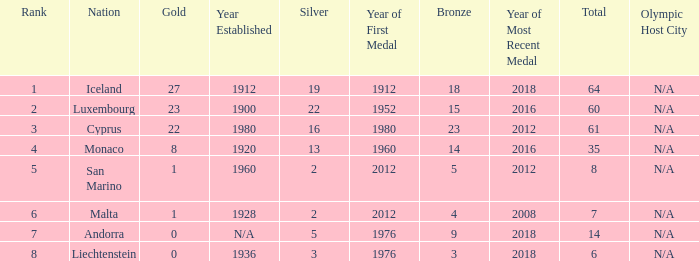How many bronzes for nations with over 22 golds and ranked under 2? 18.0. 